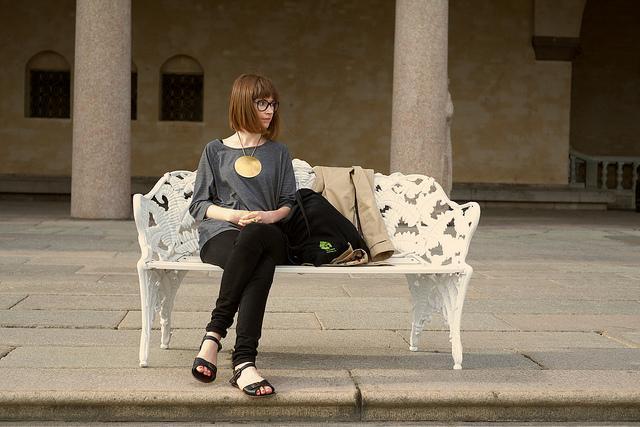How many people are depicted?
Give a very brief answer. 1. How many dogs are in the picture?
Give a very brief answer. 0. 